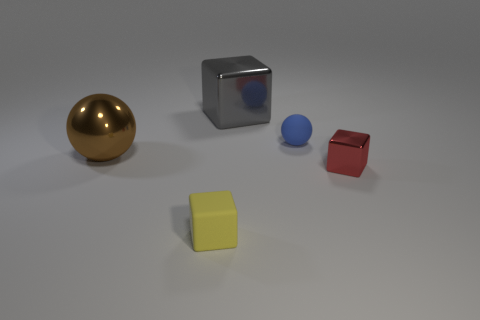The big metallic object in front of the big block has what shape?
Provide a succinct answer. Sphere. How many other matte things are the same size as the yellow matte object?
Offer a very short reply. 1. What is the color of the rubber cube?
Make the answer very short. Yellow. What size is the gray thing that is made of the same material as the large brown ball?
Your answer should be compact. Large. What number of objects are red objects to the right of the blue rubber sphere or blue rubber spheres?
Provide a short and direct response. 2. Do the tiny yellow object and the ball that is behind the big brown shiny sphere have the same material?
Keep it short and to the point. Yes. Is there a small cube that has the same material as the blue sphere?
Your answer should be very brief. Yes. How many things are tiny things that are behind the yellow matte cube or big metallic things behind the large brown ball?
Provide a short and direct response. 3. Does the tiny blue object have the same shape as the object behind the small rubber ball?
Provide a short and direct response. No. What number of other things are there of the same shape as the tiny yellow rubber object?
Make the answer very short. 2. 